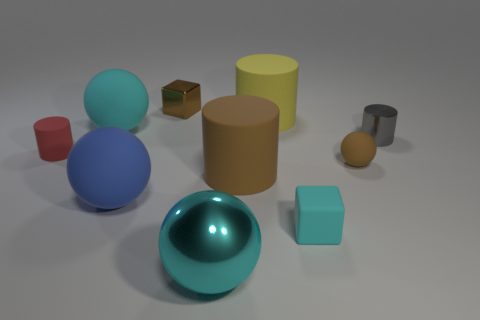Is there anything else that has the same color as the big shiny sphere?
Your response must be concise. Yes. How many things are on the right side of the blue thing and in front of the brown shiny thing?
Offer a very short reply. 6. There is a cyan ball in front of the small cyan object; does it have the same size as the cyan matte thing that is left of the large shiny object?
Your response must be concise. Yes. What number of objects are either large matte cylinders behind the red rubber object or small things?
Provide a succinct answer. 6. What is the small brown thing that is in front of the tiny brown cube made of?
Give a very brief answer. Rubber. What is the material of the yellow object?
Provide a short and direct response. Rubber. The tiny cube in front of the large matte thing behind the large matte ball behind the brown matte sphere is made of what material?
Offer a terse response. Rubber. Are there any other things that are made of the same material as the red object?
Your answer should be very brief. Yes. There is a matte block; is its size the same as the cyan sphere right of the small brown metal block?
Your response must be concise. No. How many objects are spheres that are behind the brown ball or big rubber things left of the large blue ball?
Your answer should be very brief. 1. 